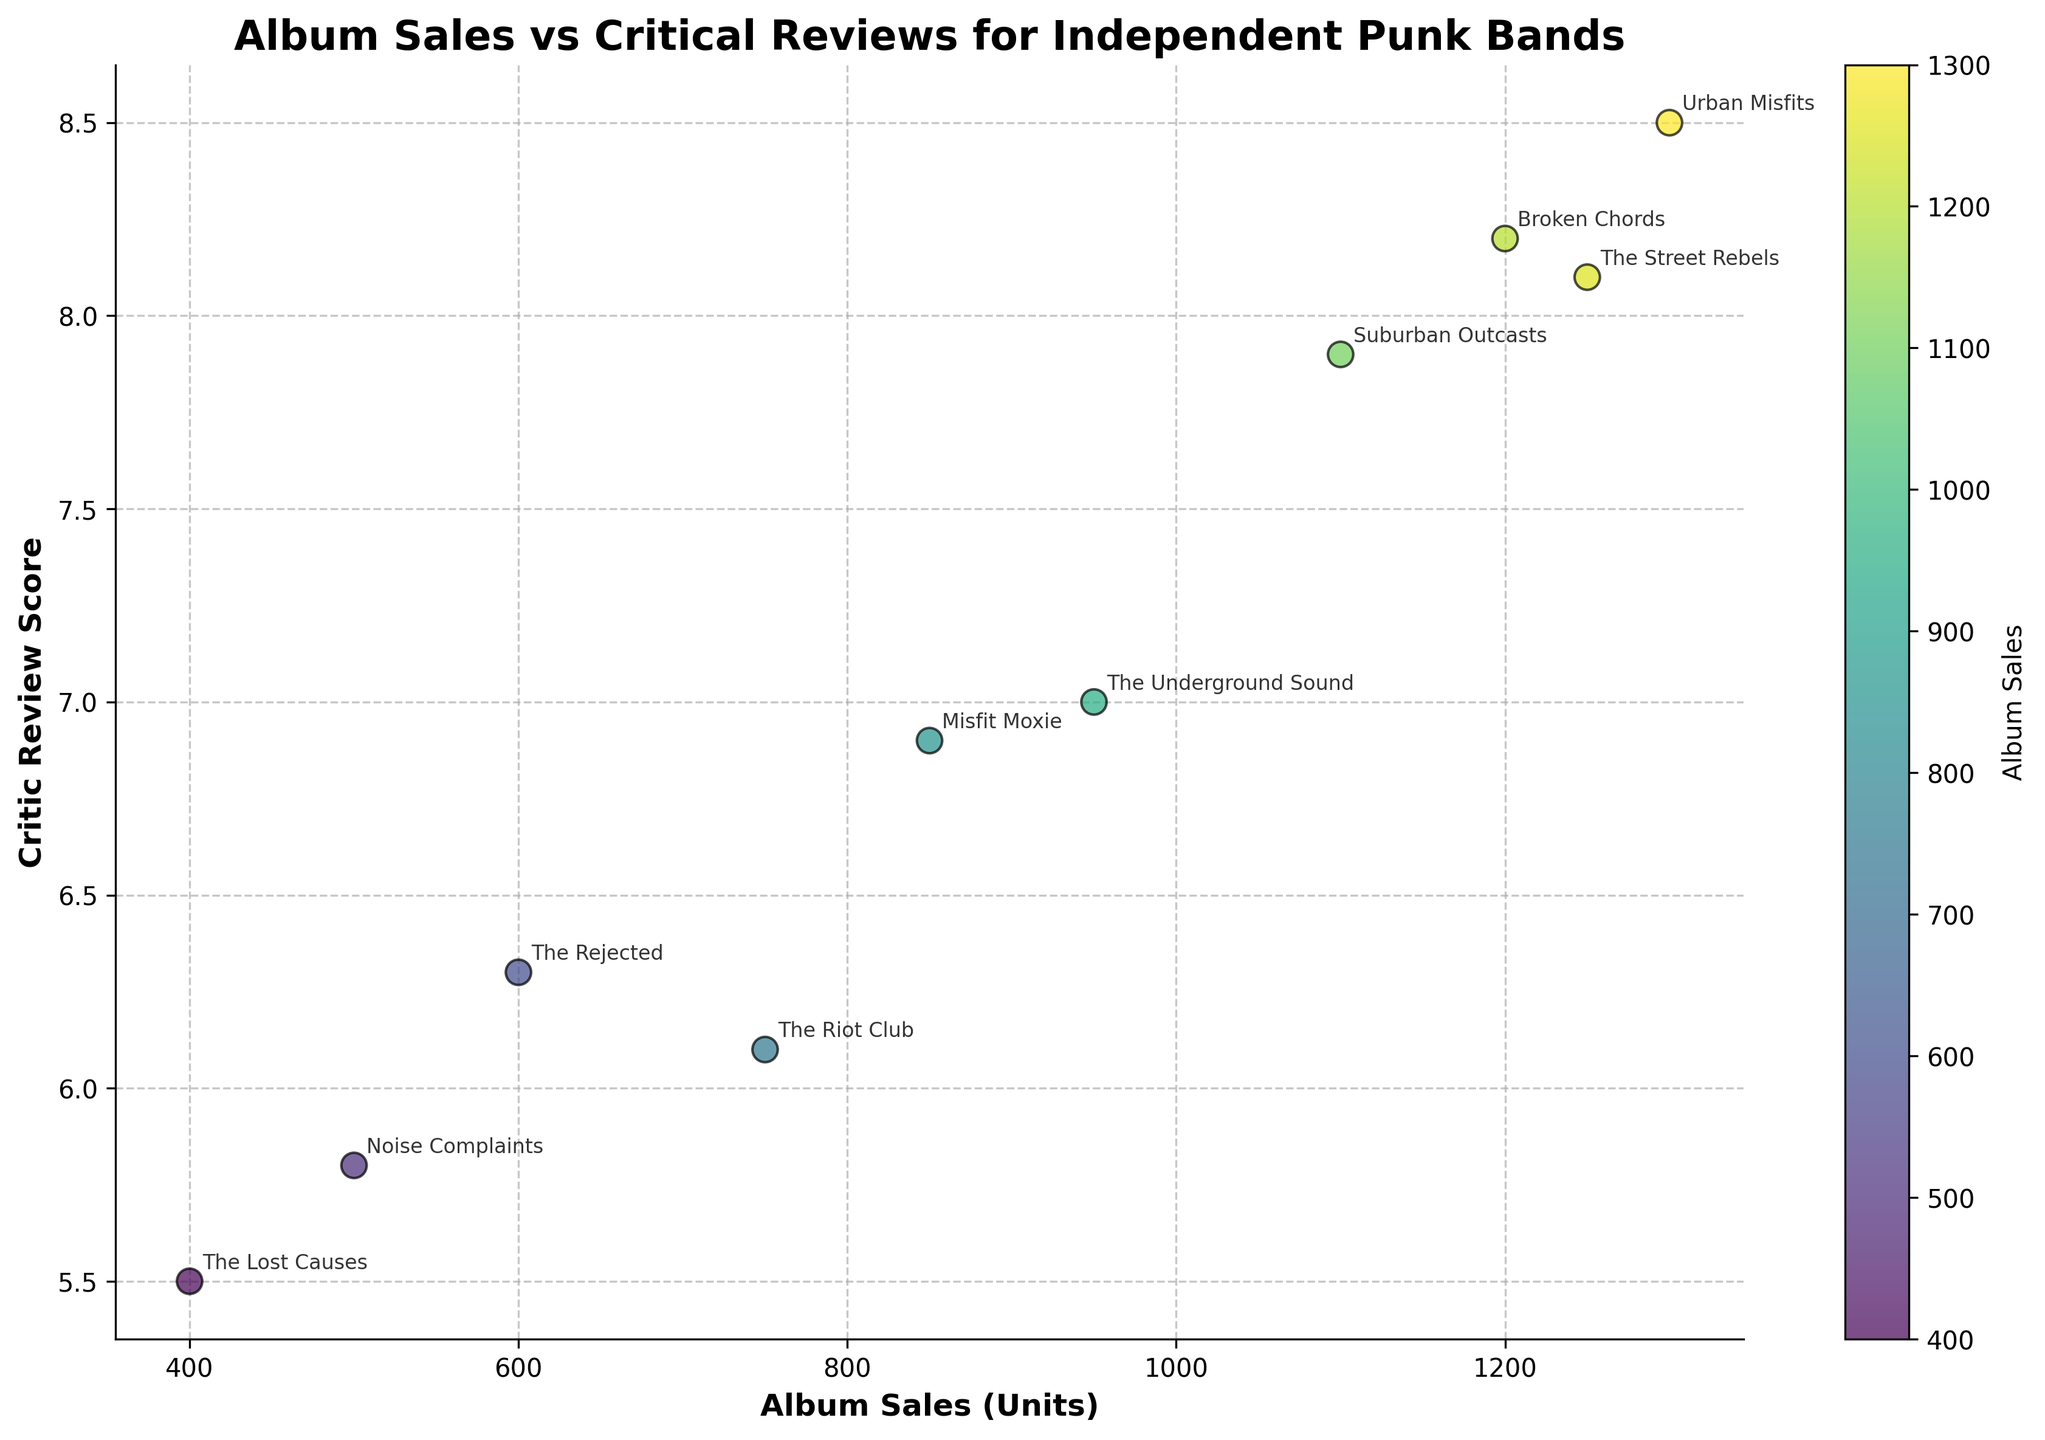What is the title of the plot? The title of the plot is located at the top and provides a brief description of the figure. In this case, it reads "Album Sales vs Critical Reviews for Independent Punk Bands."
Answer: Album Sales vs Critical Reviews for Independent Punk Bands How many data points are represented in the figure? Each data point represents a band, with its sales and review score. Counting all the annotated bands gives us the total number of data points.
Answer: 10 Which band has the highest critic review score, and what is that score? By inspecting the points and their annotations, we see that Urban Misfits, with the album "Chaos Theory," has the highest score, which is 8.5.
Answer: Urban Misfits, 8.5 Which band achieved the highest album sales units, and what is the value? The point with the highest value on the x-axis indicates this. The label shows Urban Misfits, with album sales of 1300 units.
Answer: Urban Misfits, 1300 Is there a visible correlation between album sales and critic review scores? By observing the scatter plot, we can determine the correlation. The plot shows a general upward trend, suggesting a positive correlation between higher reviews and higher sales.
Answer: Yes, positive correlation Which band has the lowest critic review score, and what is the score? The point with the lowest value on the y-axis denotes this. The label shows The Lost Causes with a score of 5.5.
Answer: The Lost Causes, 5.5 What is the average critic review score for the bands in the plot? Sum all the critic review scores and divide by the number of bands: (6.1 + 8.2 + 7.0 + 5.8 + 7.9 + 5.5 + 8.5 + 6.9 + 6.3 + 8.1) / 10. This calculation gives an average score of 7.03.
Answer: 7.03 Which band with album sales less than 800 units has the highest critic review score? Reviewing the plot, we see that the band The Riot Club, with 750 sales and a 6.1 review score, is the highest-scoring band under 800 units.
Answer: The Riot Club Which bands have the same album sales figures, and what are those figures? By comparing the x-axis values, we see that Noise Complaints and The Rejected both have 600 units in album sales.
Answer: Noise Complaints, The Rejected, 600 What is the color indication used in the scatter plot? The color of the points ranges from blue to yellow, indicating the number of album sales, with the color bar showing this gradient.
Answer: Album Sales 